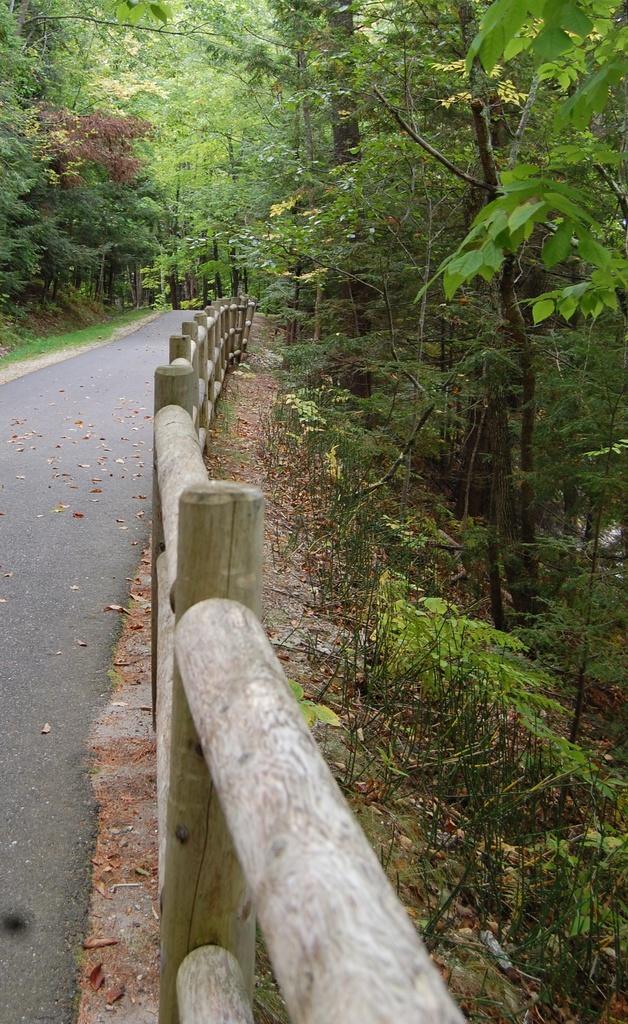In one or two sentences, can you explain what this image depicts? In this image there is a road at the center and on both right and left side of the image there are trees. 